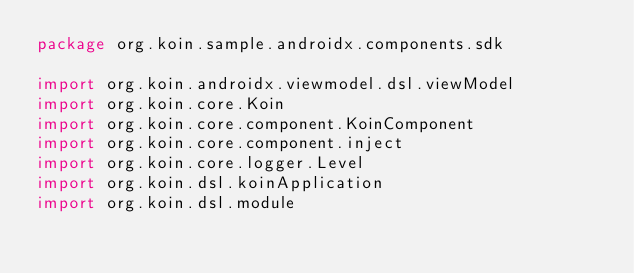<code> <loc_0><loc_0><loc_500><loc_500><_Kotlin_>package org.koin.sample.androidx.components.sdk

import org.koin.androidx.viewmodel.dsl.viewModel
import org.koin.core.Koin
import org.koin.core.component.KoinComponent
import org.koin.core.component.inject
import org.koin.core.logger.Level
import org.koin.dsl.koinApplication
import org.koin.dsl.module</code> 